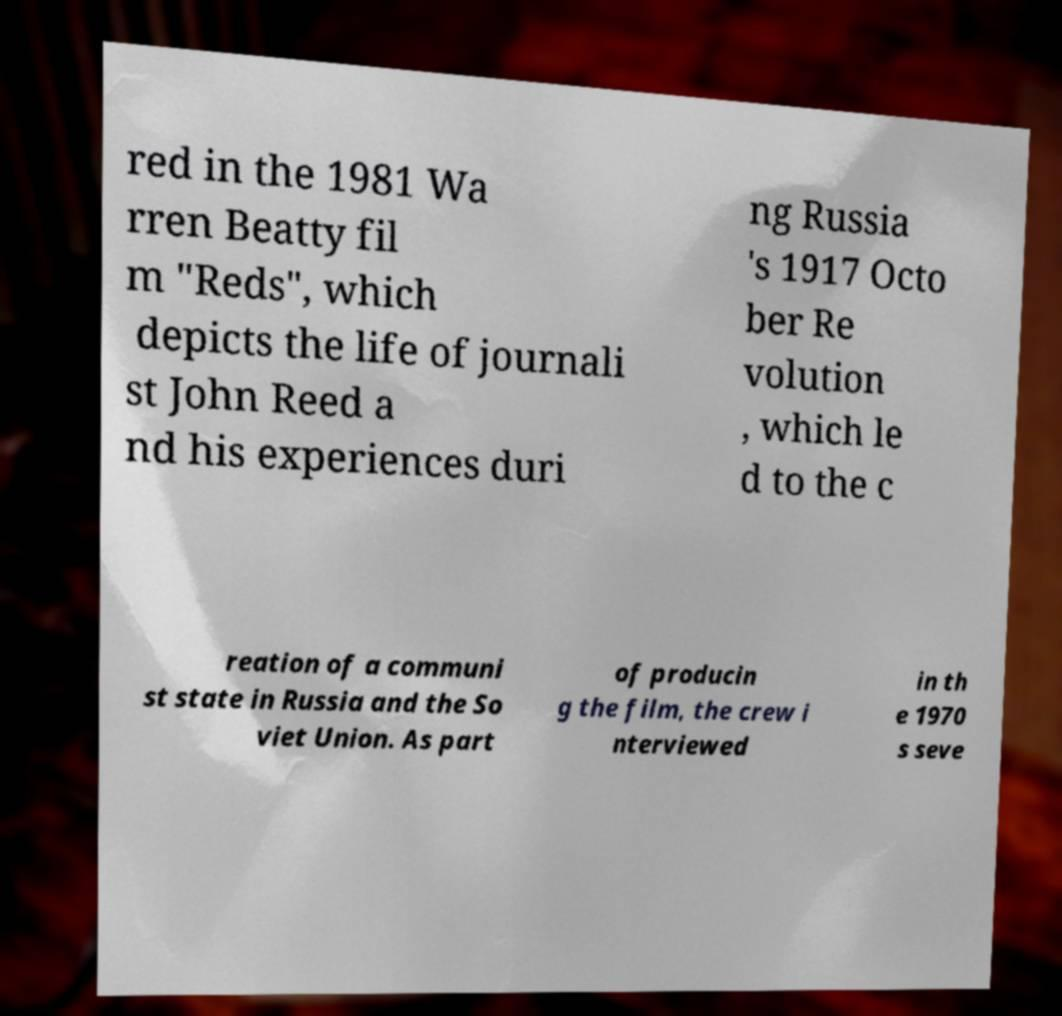There's text embedded in this image that I need extracted. Can you transcribe it verbatim? red in the 1981 Wa rren Beatty fil m "Reds", which depicts the life of journali st John Reed a nd his experiences duri ng Russia 's 1917 Octo ber Re volution , which le d to the c reation of a communi st state in Russia and the So viet Union. As part of producin g the film, the crew i nterviewed in th e 1970 s seve 